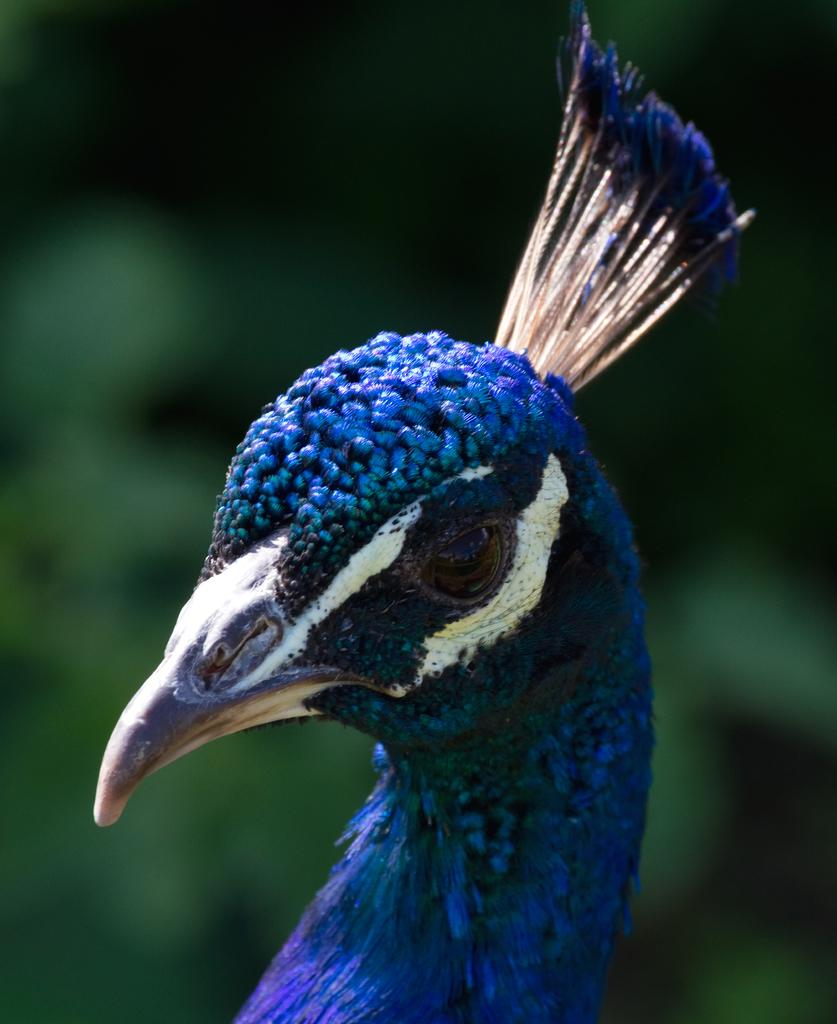What animal's head is the main subject of the image? The image features the head of a peacock. What features can be seen on the peacock's head? The peacock has eyes and a beak. What color is the peacock in the image? The peacock is in blue color. What type of banana is the peacock holding in its beak in the image? There is no banana present in the image; it features the head of a peacock. Is there a rat visible in the image? No, there is no rat present in the image. 